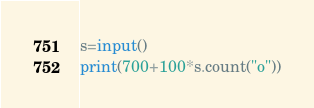<code> <loc_0><loc_0><loc_500><loc_500><_Python_>s=input()
print(700+100*s.count("o"))</code> 